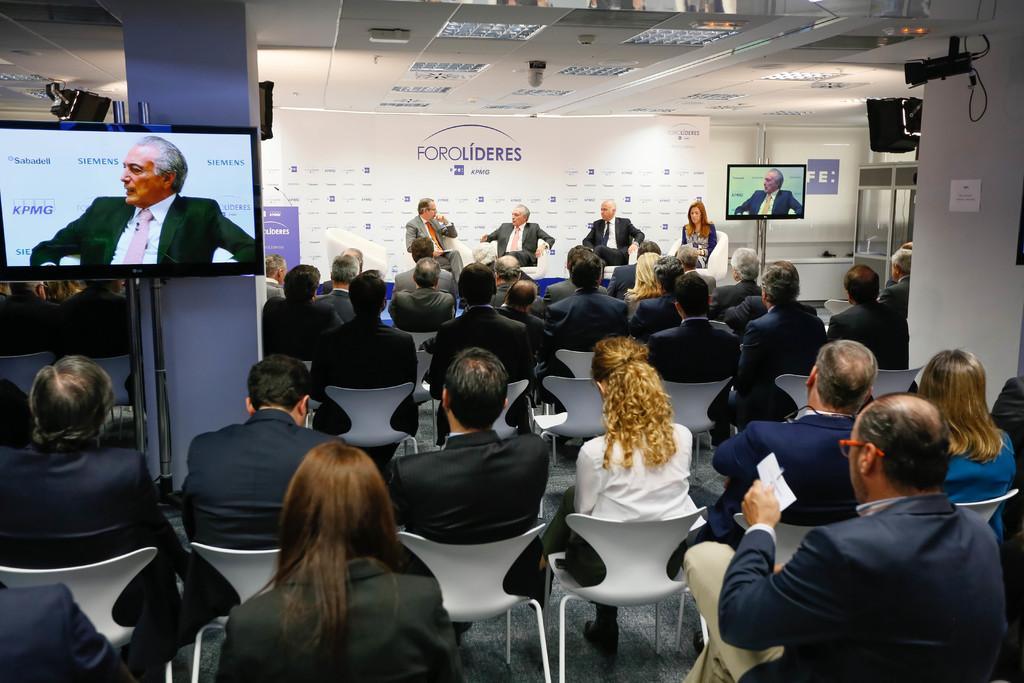Describe this image in one or two sentences. Most of the persons are sitting on a chair. In-front of this pillar there is a television with stand. Far these persons are sitting on a chair. Beside this woman there is a television with stand. A paper on wall. 